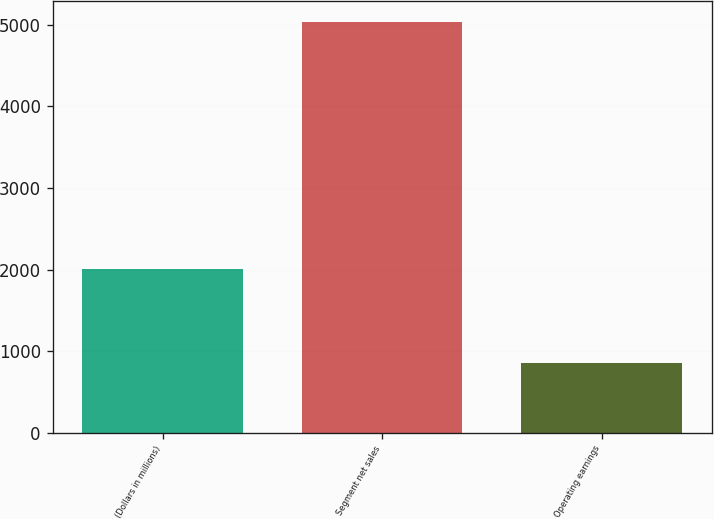Convert chart to OTSL. <chart><loc_0><loc_0><loc_500><loc_500><bar_chart><fcel>(Dollars in millions)<fcel>Segment net sales<fcel>Operating earnings<nl><fcel>2005<fcel>5038<fcel>860<nl></chart> 